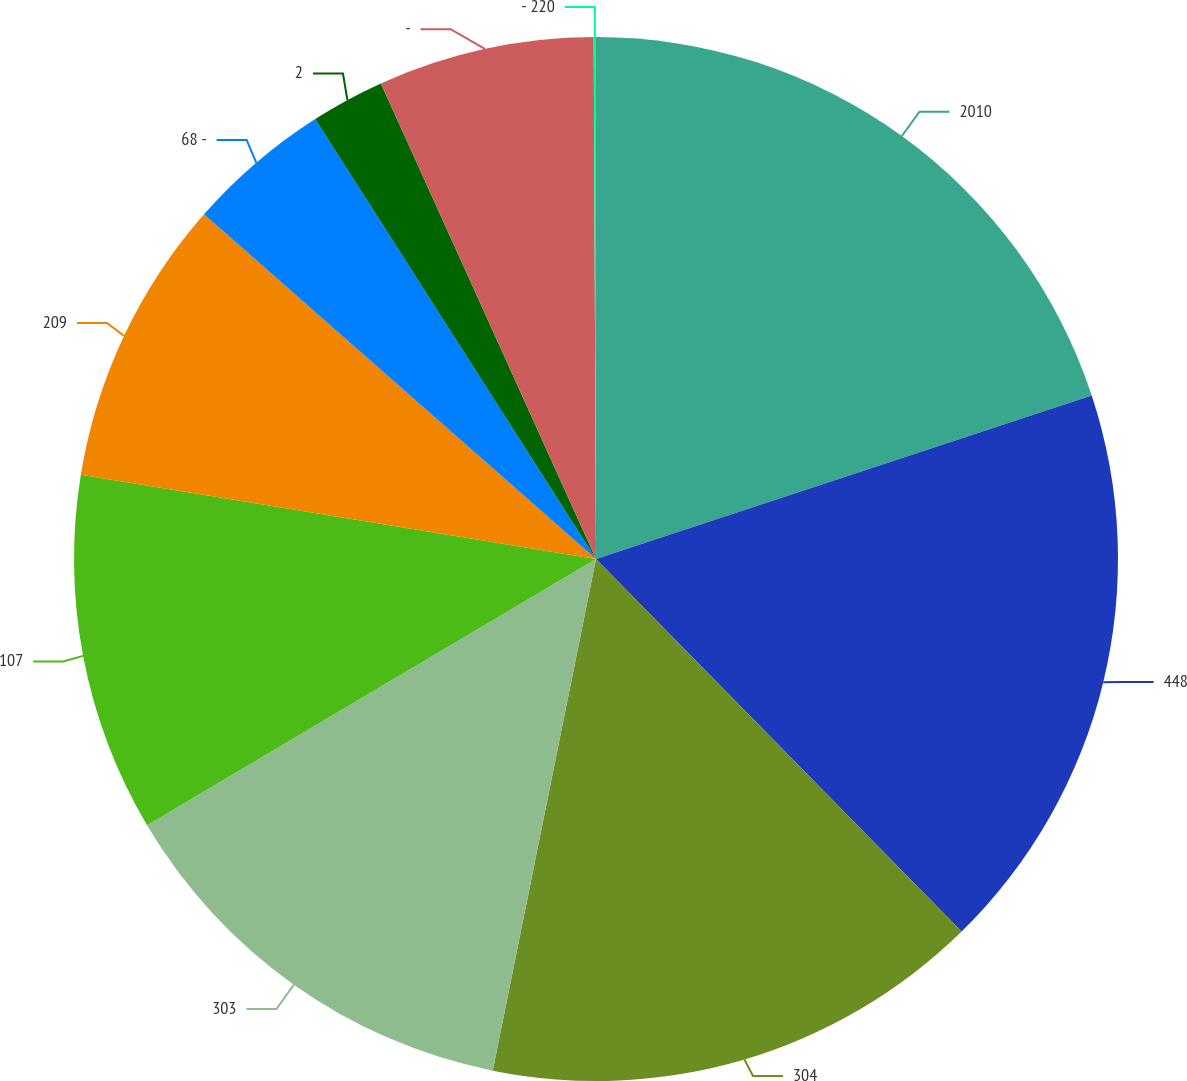<chart> <loc_0><loc_0><loc_500><loc_500><pie_chart><fcel>2010<fcel>448<fcel>304<fcel>303<fcel>107<fcel>209<fcel>68 -<fcel>2<fcel>-<fcel>- 220<nl><fcel>19.93%<fcel>17.72%<fcel>15.52%<fcel>13.31%<fcel>11.1%<fcel>8.9%<fcel>4.48%<fcel>2.28%<fcel>6.69%<fcel>0.07%<nl></chart> 